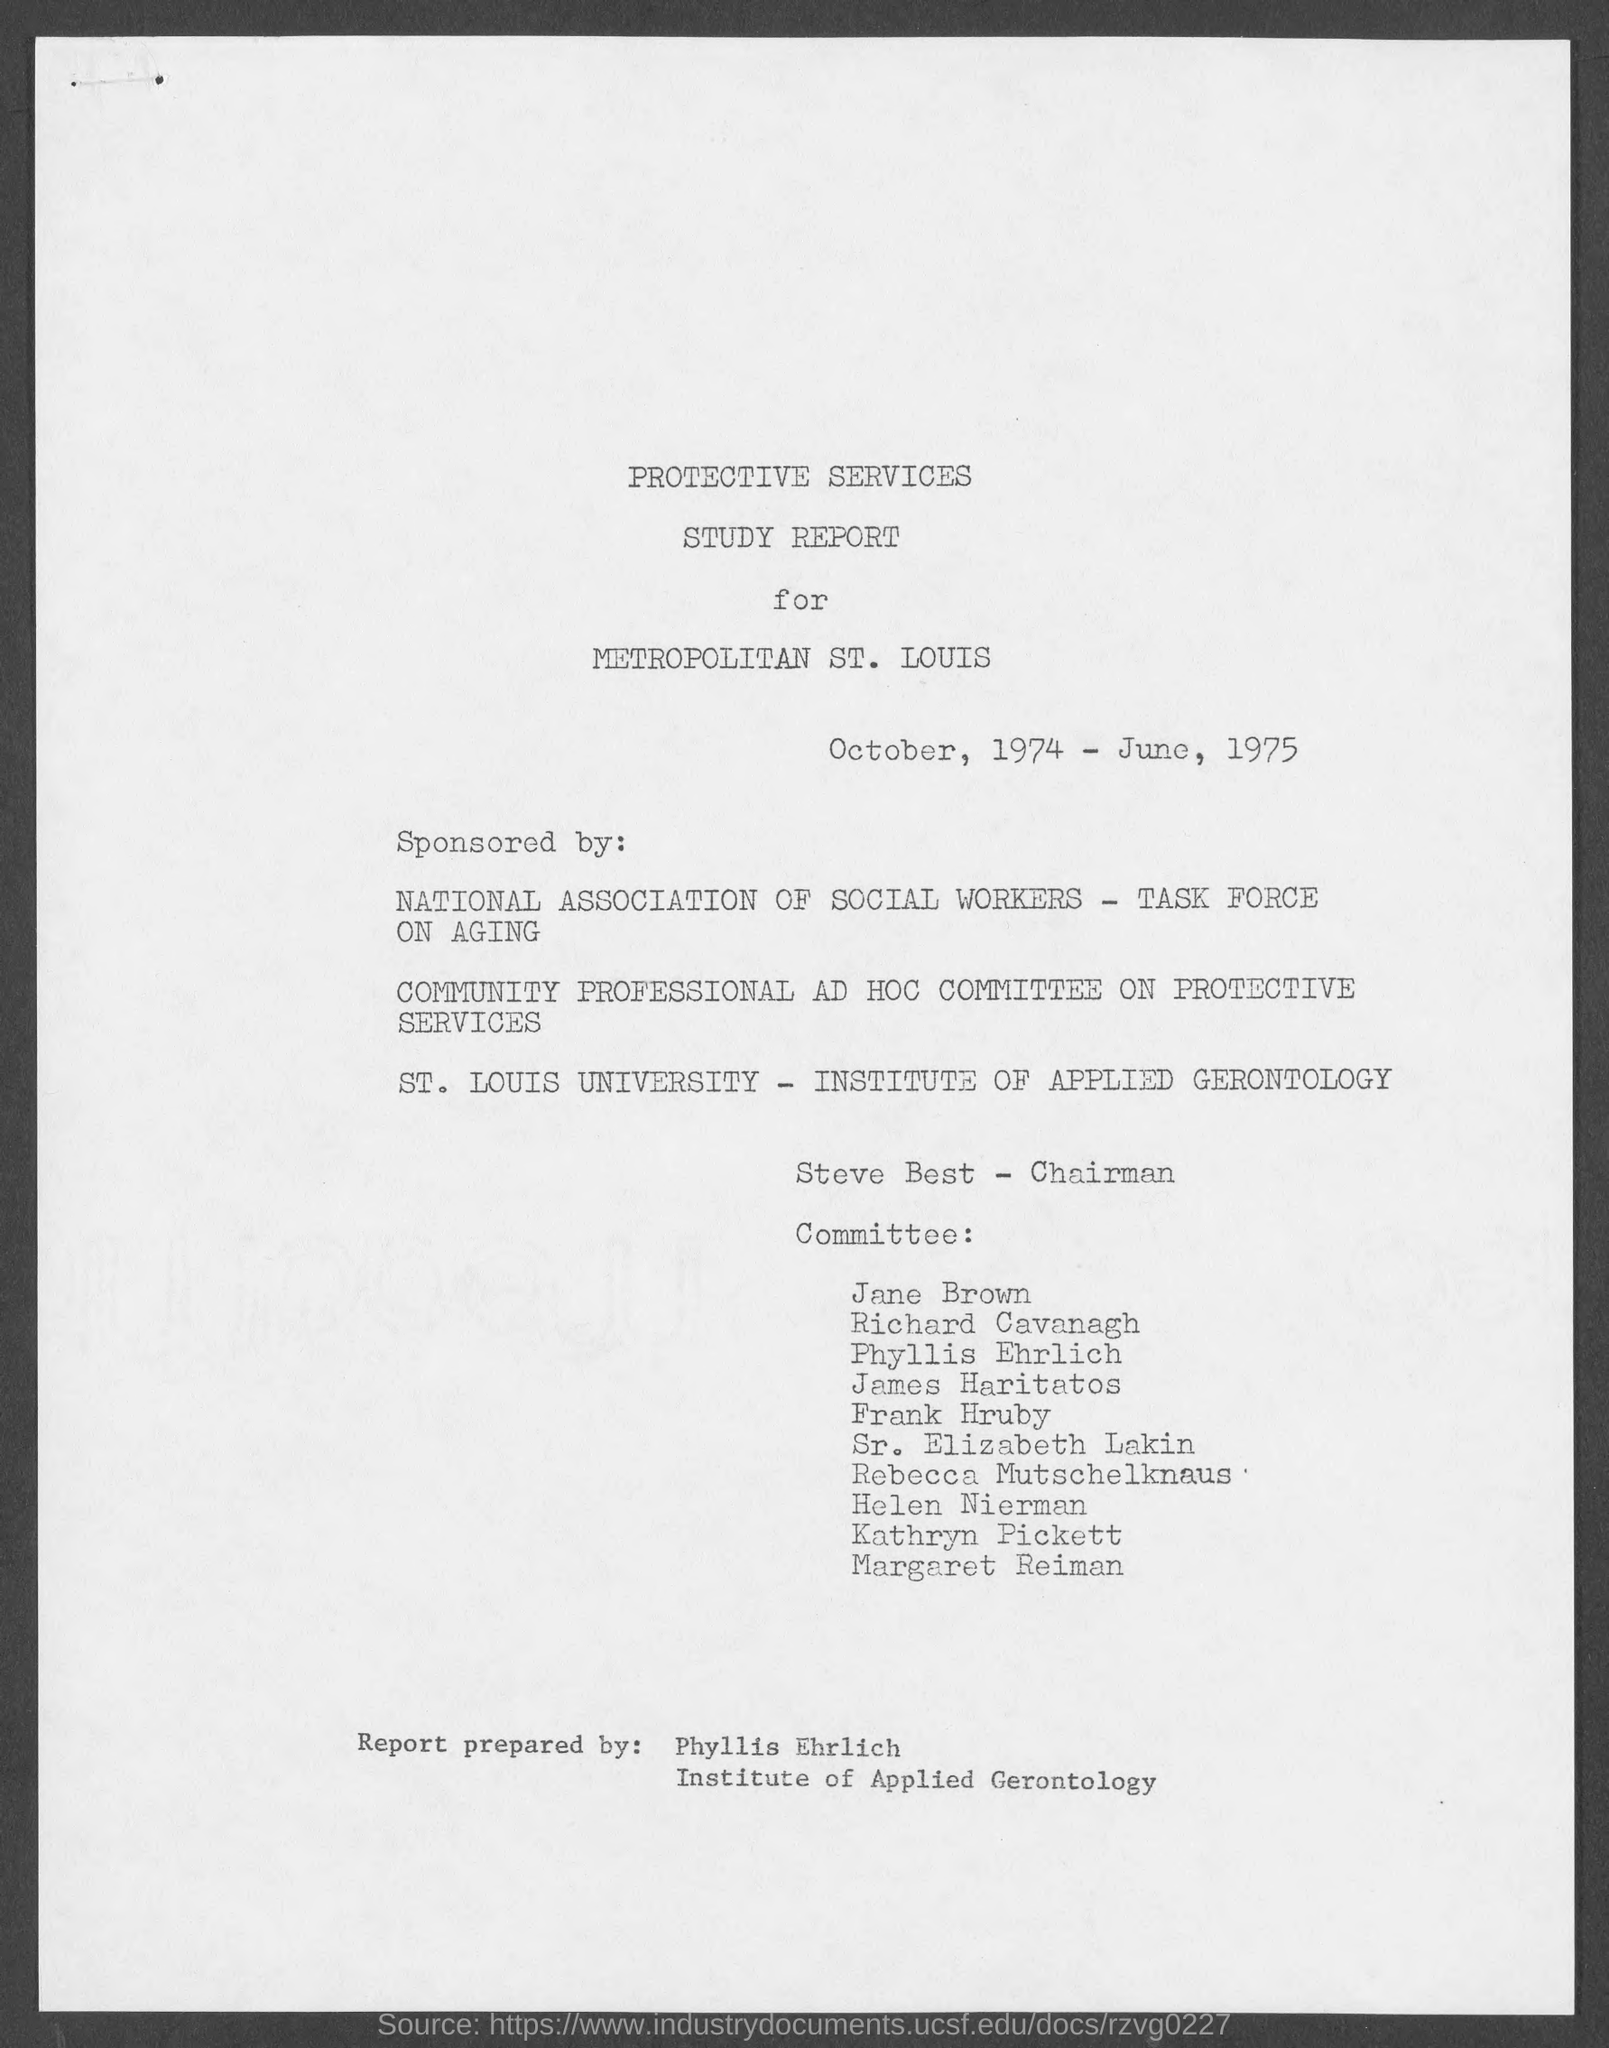Mention a couple of crucial points in this snapshot. The speaker in the report is Steve Best. The person who prepared this report is Phyllis Ehrlich. 